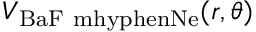Convert formula to latex. <formula><loc_0><loc_0><loc_500><loc_500>V _ { B a F \ m h y p h e n N e } ( r , \theta )</formula> 